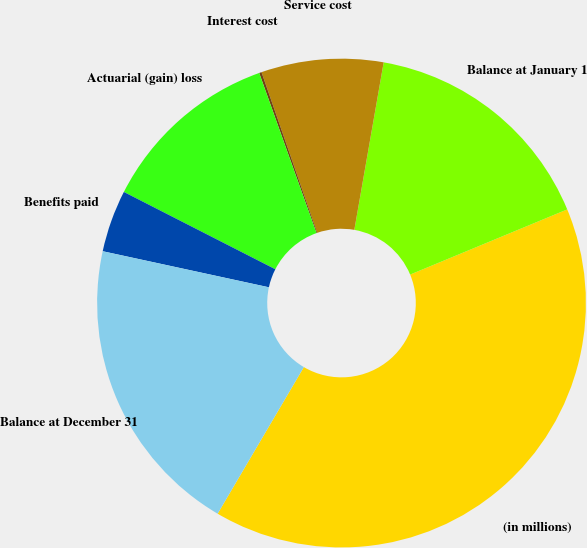Convert chart to OTSL. <chart><loc_0><loc_0><loc_500><loc_500><pie_chart><fcel>(in millions)<fcel>Balance at January 1<fcel>Service cost<fcel>Interest cost<fcel>Actuarial (gain) loss<fcel>Benefits paid<fcel>Balance at December 31<nl><fcel>39.72%<fcel>15.98%<fcel>8.07%<fcel>0.16%<fcel>12.02%<fcel>4.11%<fcel>19.94%<nl></chart> 